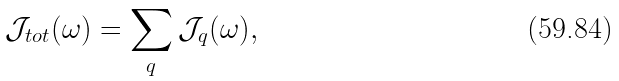Convert formula to latex. <formula><loc_0><loc_0><loc_500><loc_500>\mathcal { J } _ { t o t } ( \omega ) = \sum _ { q } \mathcal { J } _ { q } ( \omega ) ,</formula> 